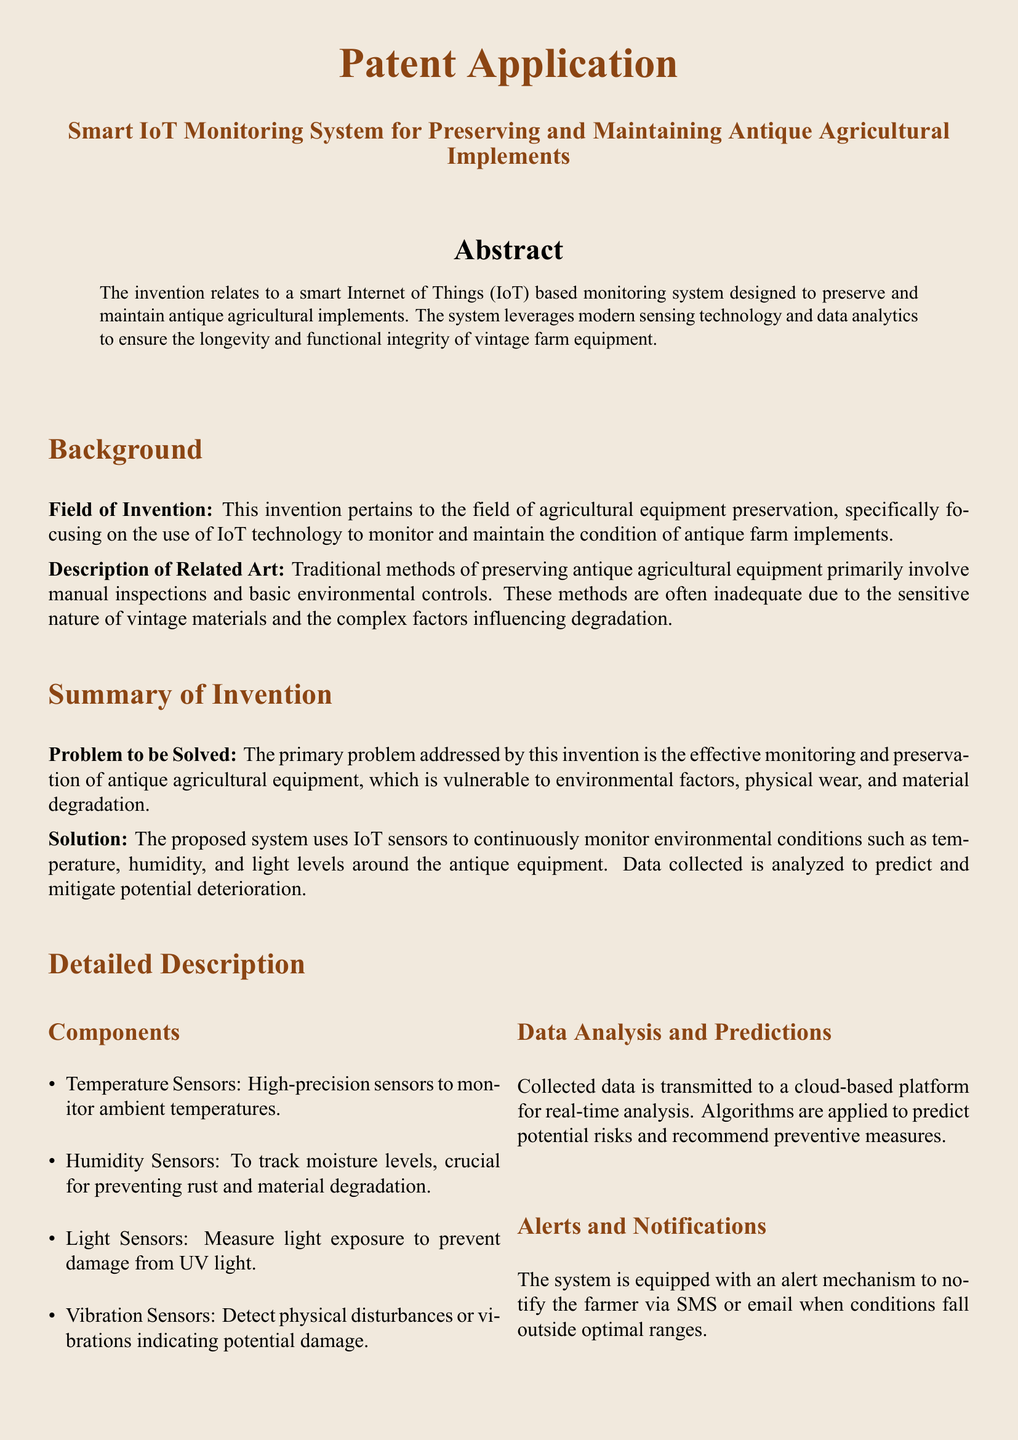What is the invention related to? The invention relates to a smart IoT based monitoring system designed to preserve and maintain antique agricultural implements.
Answer: smart IoT based monitoring system What does the problem primarily address? The problem addressed by this invention is the effective monitoring and preservation of antique agricultural equipment.
Answer: effective monitoring and preservation What types of sensors are used in the system? The document lists several sensors including temperature, humidity, light, and vibration sensors that are integral to the system.
Answer: temperature, humidity, light, vibration What kind of data analysis is performed? Data collected is analyzed in a cloud-based platform to predict potential risks and recommend preventive measures.
Answer: cloud-based platform analysis What is one advantage of the proposed system? One advantage of the proposed system is the proactive identification of potential issues with the antique equipment.
Answer: proactive identification How are farmers notified of environmental changes? The system has an alert mechanism that notifies the farmer via SMS or email when conditions fall outside optimal ranges.
Answer: SMS or email What does the historical data enable? The maintenance of a database enables long-term trend analysis for the antique equipment preservation.
Answer: long-term trend analysis What is the primary field of invention? The primary field of invention pertains to agricultural equipment preservation.
Answer: agricultural equipment preservation 